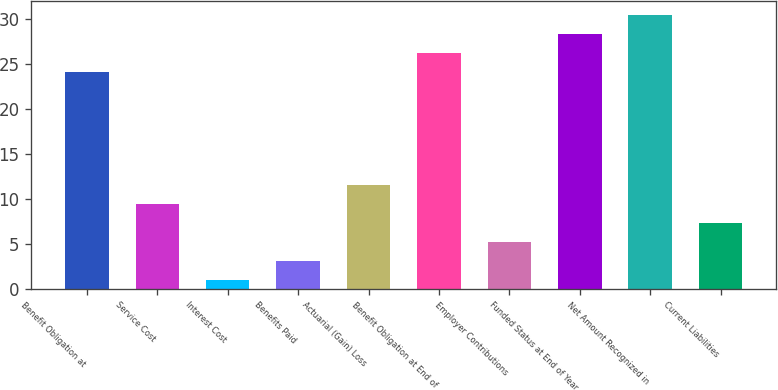<chart> <loc_0><loc_0><loc_500><loc_500><bar_chart><fcel>Benefit Obligation at<fcel>Service Cost<fcel>Interest Cost<fcel>Benefits Paid<fcel>Actuarial (Gain) Loss<fcel>Benefit Obligation at End of<fcel>Employer Contributions<fcel>Funded Status at End of Year<fcel>Net Amount Recognized in<fcel>Current Liabilities<nl><fcel>24.1<fcel>9.4<fcel>1<fcel>3.1<fcel>11.5<fcel>26.2<fcel>5.2<fcel>28.3<fcel>30.4<fcel>7.3<nl></chart> 